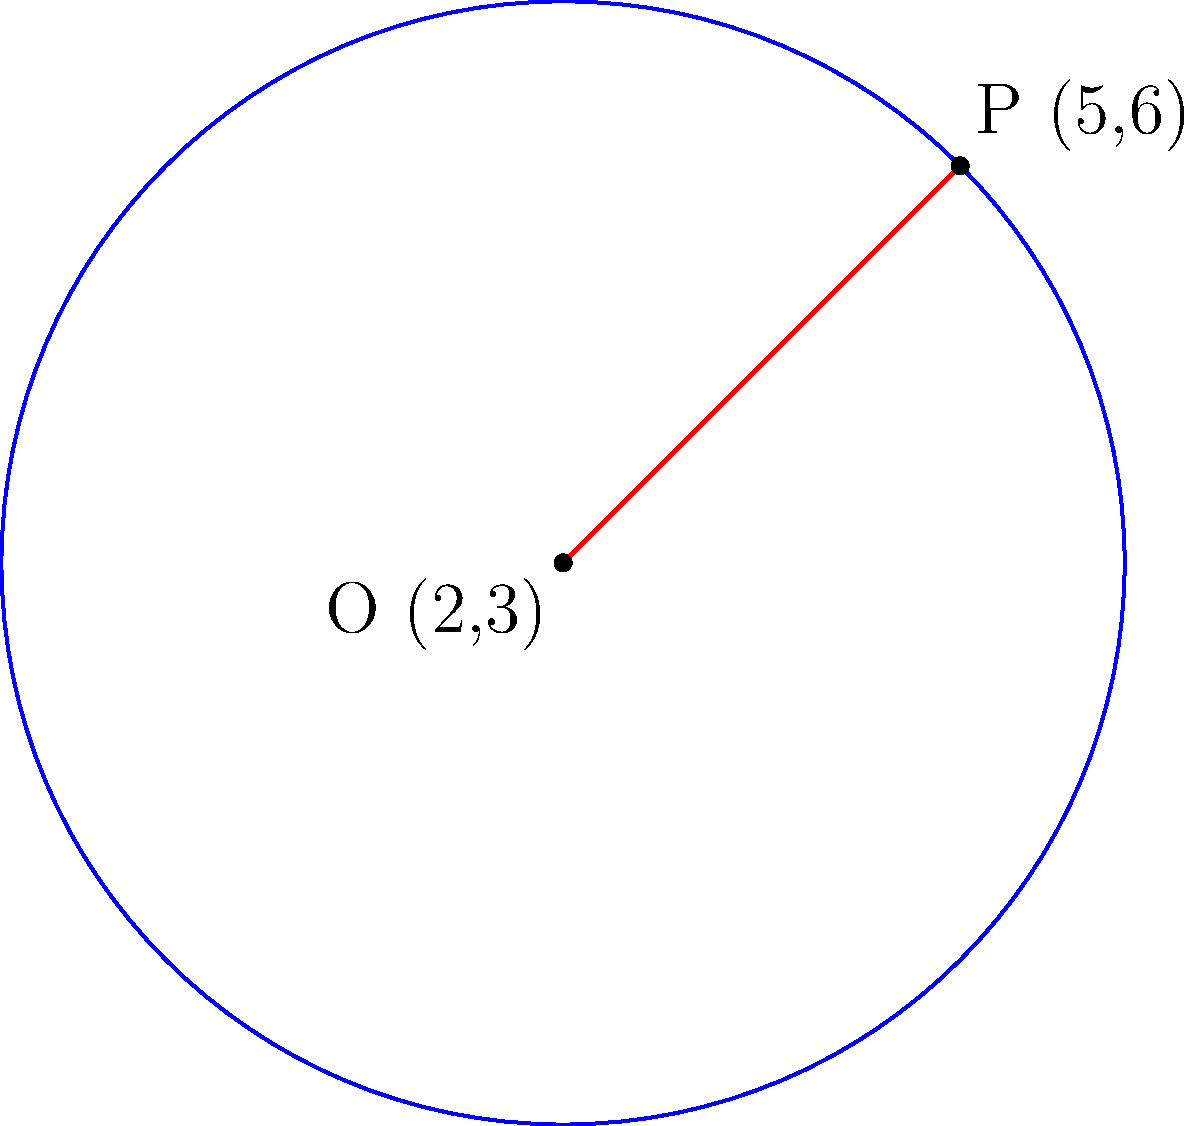In the coordinate plane, a circle has its center at point O(2,3) and passes through point P(5,6). Determine the equation of this circle. To find the equation of the circle, we can follow these steps:

1) The general equation of a circle is $$(x-h)^2 + (y-k)^2 = r^2$$
   where (h,k) is the center and r is the radius.

2) We're given the center O(2,3), so h = 2 and k = 3.

3) To find r, we can calculate the distance between O and P:
   $$r^2 = (x_P - x_O)^2 + (y_P - y_O)^2$$
   $$r^2 = (5-2)^2 + (6-3)^2 = 3^2 + 3^2 = 18$$

4) Now we can substitute these values into the general equation:
   $$(x-2)^2 + (y-3)^2 = 18$$

5) This is the equation of the circle in standard form.
Answer: $(x-2)^2 + (y-3)^2 = 18$ 